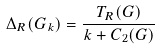Convert formula to latex. <formula><loc_0><loc_0><loc_500><loc_500>\Delta _ { R } ( G _ { k } ) = \frac { T _ { R } ( G ) } { k + C _ { 2 } ( G ) }</formula> 